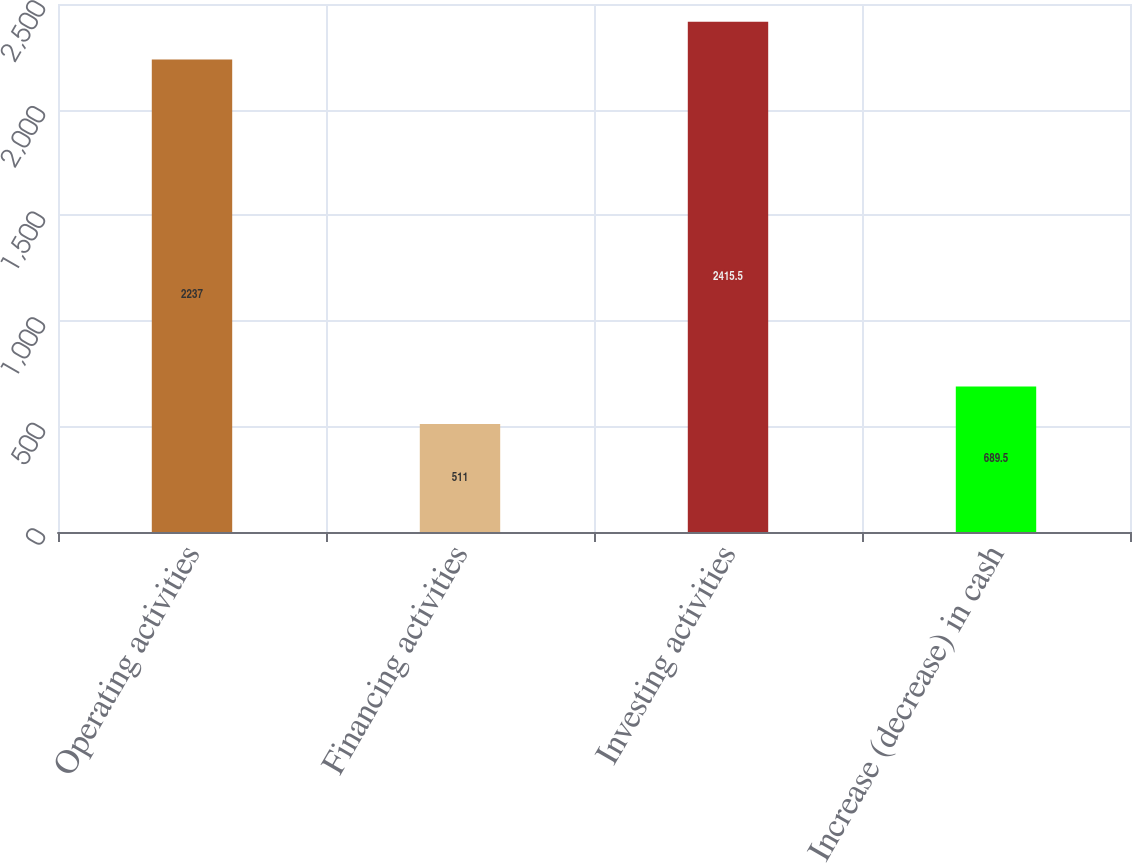Convert chart to OTSL. <chart><loc_0><loc_0><loc_500><loc_500><bar_chart><fcel>Operating activities<fcel>Financing activities<fcel>Investing activities<fcel>Increase (decrease) in cash<nl><fcel>2237<fcel>511<fcel>2415.5<fcel>689.5<nl></chart> 